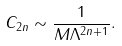<formula> <loc_0><loc_0><loc_500><loc_500>C _ { 2 n } \sim \frac { 1 } { M \Lambda ^ { 2 n + 1 } } .</formula> 